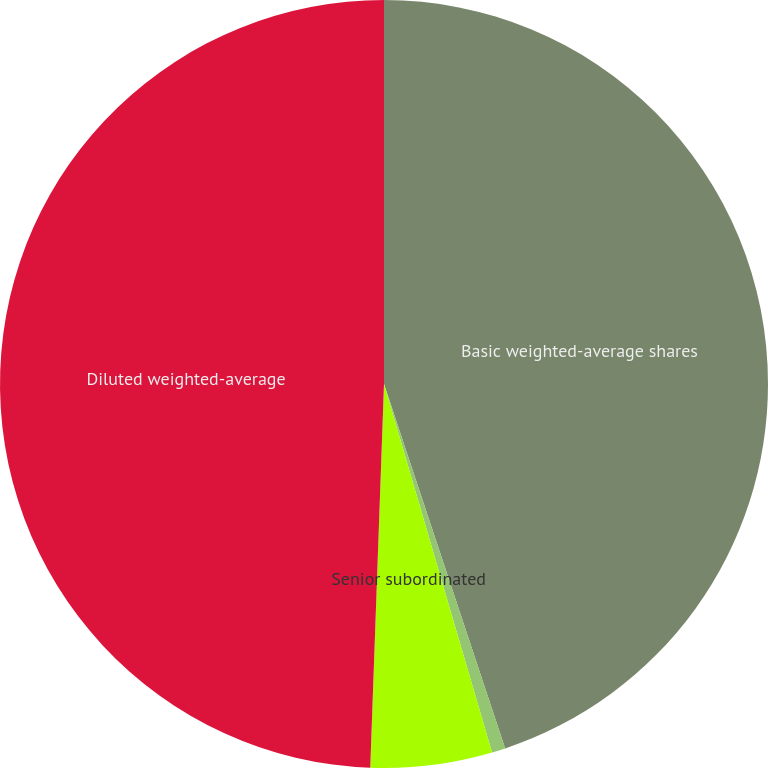Convert chart to OTSL. <chart><loc_0><loc_0><loc_500><loc_500><pie_chart><fcel>Basic weighted-average shares<fcel>Common stock awards<fcel>Senior subordinated<fcel>Diluted weighted-average<nl><fcel>44.89%<fcel>0.57%<fcel>5.11%<fcel>49.43%<nl></chart> 